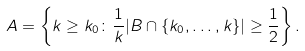Convert formula to latex. <formula><loc_0><loc_0><loc_500><loc_500>A = \left \{ k \geq k _ { 0 } \colon \frac { 1 } { k } | B \cap \{ k _ { 0 } , \dots , k \} | \geq \frac { 1 } { 2 } \right \} .</formula> 